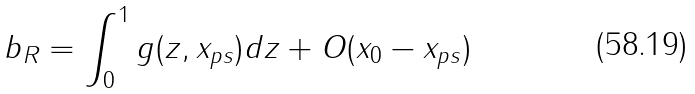<formula> <loc_0><loc_0><loc_500><loc_500>b _ { R } = \int _ { 0 } ^ { 1 } g ( z , x _ { p s } ) d z + O ( x _ { 0 } - x _ { p s } )</formula> 